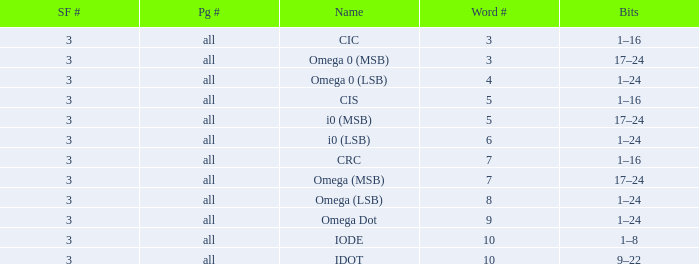What is the total word count with a subframe count greater than 3? None. 